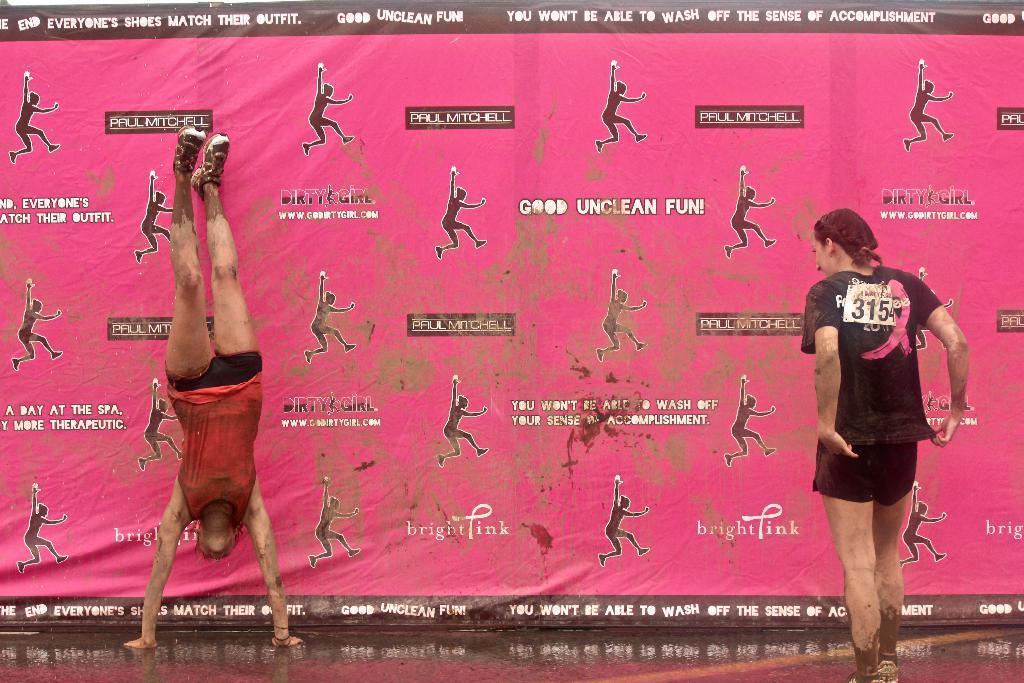In one or two sentences, can you explain what this image depicts? In this image there is a person upside down. Right side there is a woman standing on the floor. Background there is a banner having images of people and some text. 